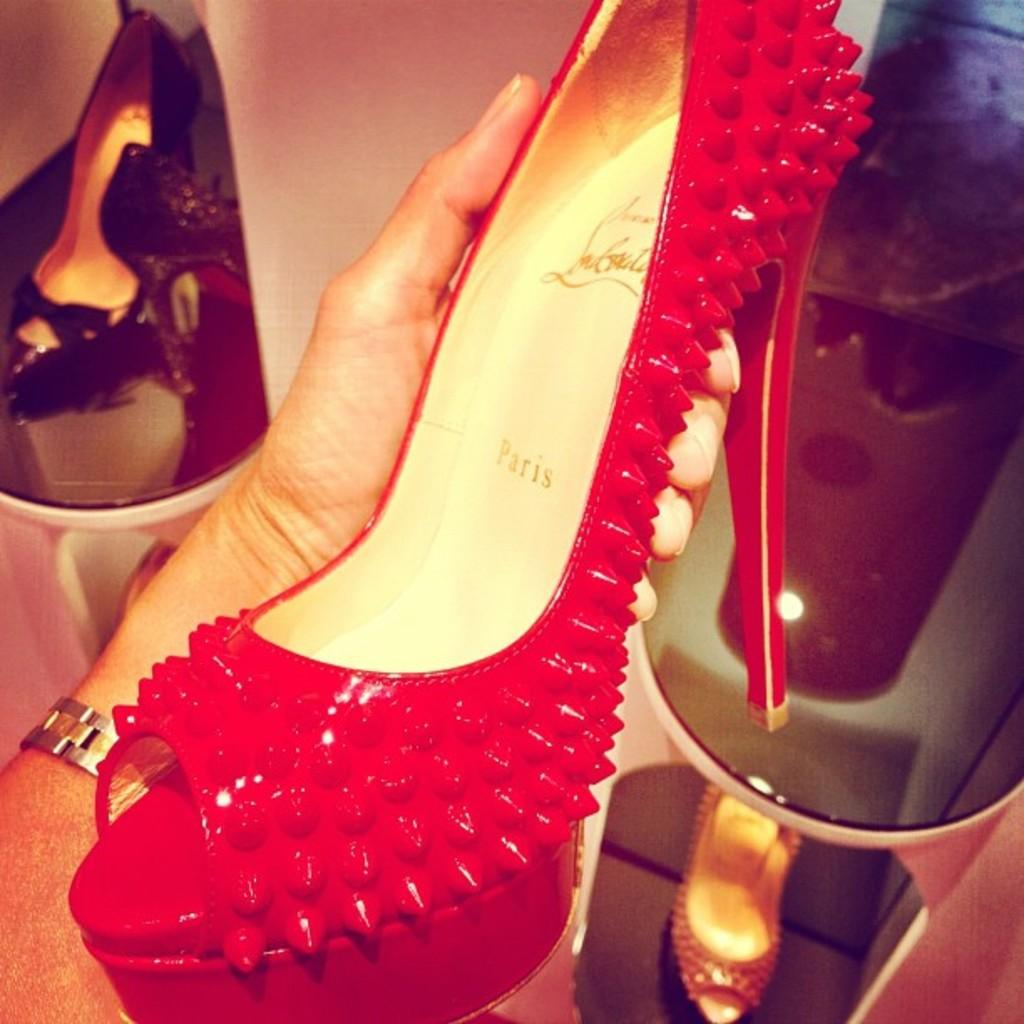What is the main subject of the image? There is a person in the image. What is the person doing in the image? The person's hand is holding a sandal. What can be seen in the background of the image? There are sandals in racks in the background of the image. Can you see any snails or jelly in the image? No, there are no snails or jelly present in the image. 